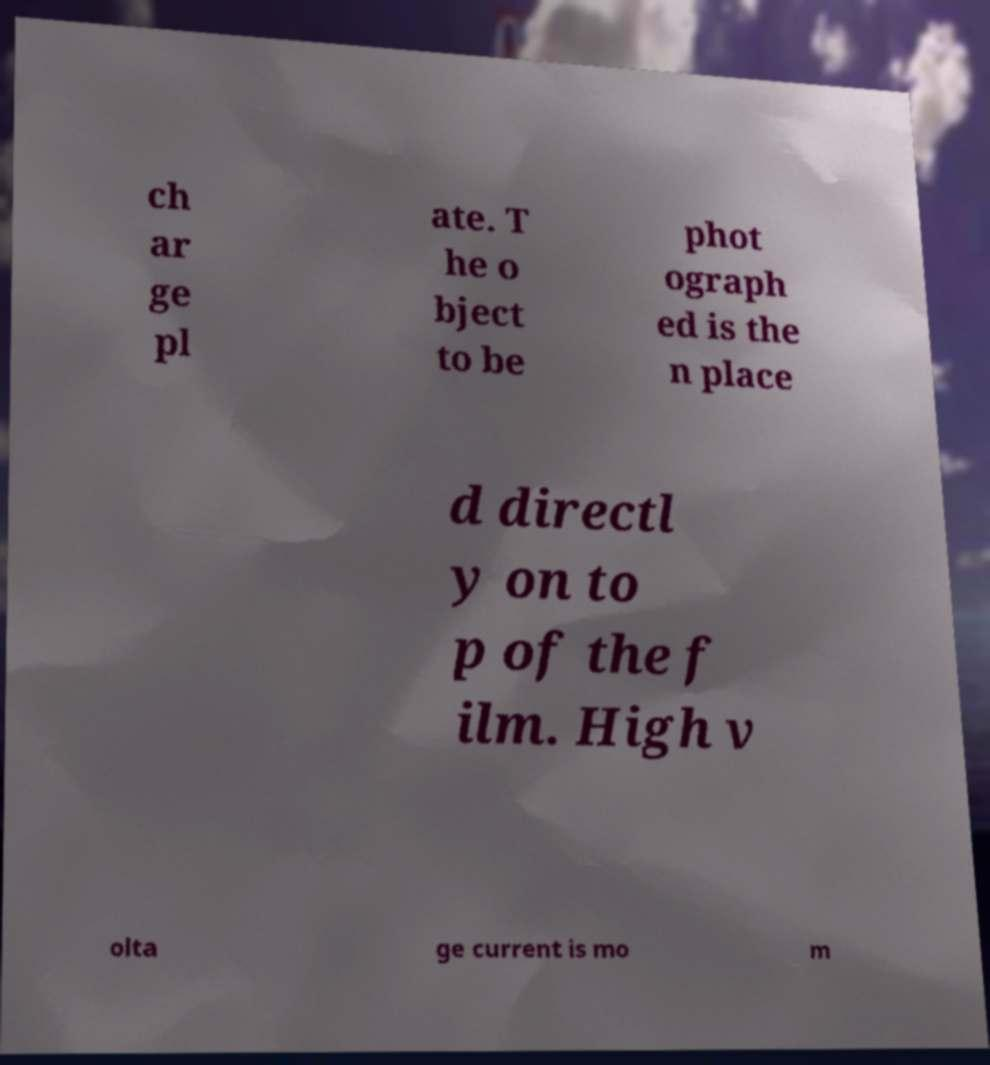What messages or text are displayed in this image? I need them in a readable, typed format. ch ar ge pl ate. T he o bject to be phot ograph ed is the n place d directl y on to p of the f ilm. High v olta ge current is mo m 